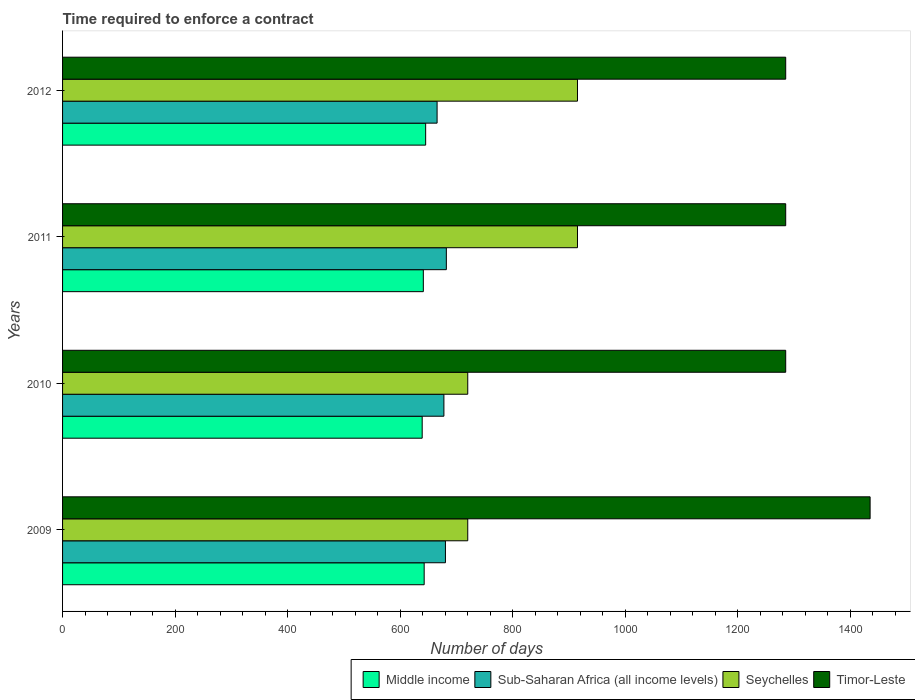How many bars are there on the 4th tick from the bottom?
Your answer should be very brief. 4. What is the label of the 2nd group of bars from the top?
Give a very brief answer. 2011. What is the number of days required to enforce a contract in Sub-Saharan Africa (all income levels) in 2012?
Provide a succinct answer. 665.52. Across all years, what is the maximum number of days required to enforce a contract in Seychelles?
Provide a succinct answer. 915. Across all years, what is the minimum number of days required to enforce a contract in Seychelles?
Keep it short and to the point. 720. In which year was the number of days required to enforce a contract in Timor-Leste minimum?
Offer a very short reply. 2010. What is the total number of days required to enforce a contract in Timor-Leste in the graph?
Give a very brief answer. 5290. What is the difference between the number of days required to enforce a contract in Sub-Saharan Africa (all income levels) in 2011 and the number of days required to enforce a contract in Timor-Leste in 2012?
Provide a short and direct response. -603.02. What is the average number of days required to enforce a contract in Middle income per year?
Your answer should be compact. 641.97. In the year 2010, what is the difference between the number of days required to enforce a contract in Sub-Saharan Africa (all income levels) and number of days required to enforce a contract in Seychelles?
Give a very brief answer. -42.36. What is the ratio of the number of days required to enforce a contract in Sub-Saharan Africa (all income levels) in 2010 to that in 2012?
Your response must be concise. 1.02. What is the difference between the highest and the second highest number of days required to enforce a contract in Sub-Saharan Africa (all income levels)?
Make the answer very short. 1.62. What is the difference between the highest and the lowest number of days required to enforce a contract in Timor-Leste?
Provide a short and direct response. 150. In how many years, is the number of days required to enforce a contract in Middle income greater than the average number of days required to enforce a contract in Middle income taken over all years?
Ensure brevity in your answer.  2. Is it the case that in every year, the sum of the number of days required to enforce a contract in Timor-Leste and number of days required to enforce a contract in Sub-Saharan Africa (all income levels) is greater than the sum of number of days required to enforce a contract in Seychelles and number of days required to enforce a contract in Middle income?
Offer a terse response. Yes. What does the 2nd bar from the top in 2009 represents?
Ensure brevity in your answer.  Seychelles. What does the 1st bar from the bottom in 2011 represents?
Offer a very short reply. Middle income. Is it the case that in every year, the sum of the number of days required to enforce a contract in Seychelles and number of days required to enforce a contract in Timor-Leste is greater than the number of days required to enforce a contract in Sub-Saharan Africa (all income levels)?
Provide a succinct answer. Yes. How many bars are there?
Your answer should be compact. 16. How many years are there in the graph?
Your answer should be very brief. 4. Does the graph contain any zero values?
Offer a very short reply. No. How many legend labels are there?
Your response must be concise. 4. What is the title of the graph?
Offer a terse response. Time required to enforce a contract. What is the label or title of the X-axis?
Ensure brevity in your answer.  Number of days. What is the Number of days in Middle income in 2009?
Your answer should be compact. 642.56. What is the Number of days in Sub-Saharan Africa (all income levels) in 2009?
Your response must be concise. 680.36. What is the Number of days in Seychelles in 2009?
Provide a short and direct response. 720. What is the Number of days in Timor-Leste in 2009?
Offer a terse response. 1435. What is the Number of days in Middle income in 2010?
Your answer should be compact. 639.04. What is the Number of days in Sub-Saharan Africa (all income levels) in 2010?
Ensure brevity in your answer.  677.64. What is the Number of days in Seychelles in 2010?
Your response must be concise. 720. What is the Number of days of Timor-Leste in 2010?
Your answer should be compact. 1285. What is the Number of days in Middle income in 2011?
Your answer should be compact. 641.06. What is the Number of days of Sub-Saharan Africa (all income levels) in 2011?
Provide a succinct answer. 681.98. What is the Number of days in Seychelles in 2011?
Ensure brevity in your answer.  915. What is the Number of days of Timor-Leste in 2011?
Offer a very short reply. 1285. What is the Number of days in Middle income in 2012?
Offer a very short reply. 645.22. What is the Number of days of Sub-Saharan Africa (all income levels) in 2012?
Keep it short and to the point. 665.52. What is the Number of days in Seychelles in 2012?
Provide a succinct answer. 915. What is the Number of days in Timor-Leste in 2012?
Your answer should be compact. 1285. Across all years, what is the maximum Number of days of Middle income?
Your answer should be very brief. 645.22. Across all years, what is the maximum Number of days of Sub-Saharan Africa (all income levels)?
Offer a very short reply. 681.98. Across all years, what is the maximum Number of days of Seychelles?
Give a very brief answer. 915. Across all years, what is the maximum Number of days of Timor-Leste?
Make the answer very short. 1435. Across all years, what is the minimum Number of days of Middle income?
Keep it short and to the point. 639.04. Across all years, what is the minimum Number of days of Sub-Saharan Africa (all income levels)?
Your response must be concise. 665.52. Across all years, what is the minimum Number of days of Seychelles?
Ensure brevity in your answer.  720. Across all years, what is the minimum Number of days in Timor-Leste?
Your answer should be very brief. 1285. What is the total Number of days of Middle income in the graph?
Keep it short and to the point. 2567.87. What is the total Number of days of Sub-Saharan Africa (all income levels) in the graph?
Give a very brief answer. 2705.5. What is the total Number of days of Seychelles in the graph?
Ensure brevity in your answer.  3270. What is the total Number of days of Timor-Leste in the graph?
Ensure brevity in your answer.  5290. What is the difference between the Number of days of Middle income in 2009 and that in 2010?
Give a very brief answer. 3.51. What is the difference between the Number of days in Sub-Saharan Africa (all income levels) in 2009 and that in 2010?
Offer a very short reply. 2.71. What is the difference between the Number of days of Seychelles in 2009 and that in 2010?
Offer a very short reply. 0. What is the difference between the Number of days of Timor-Leste in 2009 and that in 2010?
Provide a succinct answer. 150. What is the difference between the Number of days in Sub-Saharan Africa (all income levels) in 2009 and that in 2011?
Your answer should be very brief. -1.62. What is the difference between the Number of days of Seychelles in 2009 and that in 2011?
Provide a short and direct response. -195. What is the difference between the Number of days of Timor-Leste in 2009 and that in 2011?
Provide a short and direct response. 150. What is the difference between the Number of days of Middle income in 2009 and that in 2012?
Provide a succinct answer. -2.66. What is the difference between the Number of days in Sub-Saharan Africa (all income levels) in 2009 and that in 2012?
Offer a terse response. 14.83. What is the difference between the Number of days in Seychelles in 2009 and that in 2012?
Make the answer very short. -195. What is the difference between the Number of days of Timor-Leste in 2009 and that in 2012?
Ensure brevity in your answer.  150. What is the difference between the Number of days in Middle income in 2010 and that in 2011?
Your answer should be compact. -2.01. What is the difference between the Number of days in Sub-Saharan Africa (all income levels) in 2010 and that in 2011?
Offer a terse response. -4.33. What is the difference between the Number of days in Seychelles in 2010 and that in 2011?
Offer a very short reply. -195. What is the difference between the Number of days in Timor-Leste in 2010 and that in 2011?
Make the answer very short. 0. What is the difference between the Number of days of Middle income in 2010 and that in 2012?
Your answer should be very brief. -6.17. What is the difference between the Number of days of Sub-Saharan Africa (all income levels) in 2010 and that in 2012?
Offer a very short reply. 12.12. What is the difference between the Number of days of Seychelles in 2010 and that in 2012?
Keep it short and to the point. -195. What is the difference between the Number of days of Middle income in 2011 and that in 2012?
Your answer should be compact. -4.16. What is the difference between the Number of days in Sub-Saharan Africa (all income levels) in 2011 and that in 2012?
Give a very brief answer. 16.46. What is the difference between the Number of days of Seychelles in 2011 and that in 2012?
Ensure brevity in your answer.  0. What is the difference between the Number of days of Middle income in 2009 and the Number of days of Sub-Saharan Africa (all income levels) in 2010?
Your answer should be compact. -35.09. What is the difference between the Number of days in Middle income in 2009 and the Number of days in Seychelles in 2010?
Your answer should be very brief. -77.44. What is the difference between the Number of days in Middle income in 2009 and the Number of days in Timor-Leste in 2010?
Provide a short and direct response. -642.44. What is the difference between the Number of days in Sub-Saharan Africa (all income levels) in 2009 and the Number of days in Seychelles in 2010?
Offer a very short reply. -39.64. What is the difference between the Number of days in Sub-Saharan Africa (all income levels) in 2009 and the Number of days in Timor-Leste in 2010?
Make the answer very short. -604.64. What is the difference between the Number of days in Seychelles in 2009 and the Number of days in Timor-Leste in 2010?
Offer a terse response. -565. What is the difference between the Number of days of Middle income in 2009 and the Number of days of Sub-Saharan Africa (all income levels) in 2011?
Your answer should be compact. -39.42. What is the difference between the Number of days in Middle income in 2009 and the Number of days in Seychelles in 2011?
Your answer should be very brief. -272.44. What is the difference between the Number of days of Middle income in 2009 and the Number of days of Timor-Leste in 2011?
Keep it short and to the point. -642.44. What is the difference between the Number of days of Sub-Saharan Africa (all income levels) in 2009 and the Number of days of Seychelles in 2011?
Provide a short and direct response. -234.64. What is the difference between the Number of days of Sub-Saharan Africa (all income levels) in 2009 and the Number of days of Timor-Leste in 2011?
Give a very brief answer. -604.64. What is the difference between the Number of days in Seychelles in 2009 and the Number of days in Timor-Leste in 2011?
Give a very brief answer. -565. What is the difference between the Number of days of Middle income in 2009 and the Number of days of Sub-Saharan Africa (all income levels) in 2012?
Offer a very short reply. -22.97. What is the difference between the Number of days in Middle income in 2009 and the Number of days in Seychelles in 2012?
Provide a short and direct response. -272.44. What is the difference between the Number of days of Middle income in 2009 and the Number of days of Timor-Leste in 2012?
Offer a very short reply. -642.44. What is the difference between the Number of days in Sub-Saharan Africa (all income levels) in 2009 and the Number of days in Seychelles in 2012?
Provide a succinct answer. -234.64. What is the difference between the Number of days in Sub-Saharan Africa (all income levels) in 2009 and the Number of days in Timor-Leste in 2012?
Provide a succinct answer. -604.64. What is the difference between the Number of days of Seychelles in 2009 and the Number of days of Timor-Leste in 2012?
Your answer should be compact. -565. What is the difference between the Number of days in Middle income in 2010 and the Number of days in Sub-Saharan Africa (all income levels) in 2011?
Make the answer very short. -42.93. What is the difference between the Number of days of Middle income in 2010 and the Number of days of Seychelles in 2011?
Your answer should be very brief. -275.96. What is the difference between the Number of days of Middle income in 2010 and the Number of days of Timor-Leste in 2011?
Offer a very short reply. -645.96. What is the difference between the Number of days of Sub-Saharan Africa (all income levels) in 2010 and the Number of days of Seychelles in 2011?
Provide a succinct answer. -237.36. What is the difference between the Number of days of Sub-Saharan Africa (all income levels) in 2010 and the Number of days of Timor-Leste in 2011?
Your answer should be compact. -607.36. What is the difference between the Number of days in Seychelles in 2010 and the Number of days in Timor-Leste in 2011?
Give a very brief answer. -565. What is the difference between the Number of days of Middle income in 2010 and the Number of days of Sub-Saharan Africa (all income levels) in 2012?
Provide a succinct answer. -26.48. What is the difference between the Number of days of Middle income in 2010 and the Number of days of Seychelles in 2012?
Keep it short and to the point. -275.96. What is the difference between the Number of days in Middle income in 2010 and the Number of days in Timor-Leste in 2012?
Offer a very short reply. -645.96. What is the difference between the Number of days in Sub-Saharan Africa (all income levels) in 2010 and the Number of days in Seychelles in 2012?
Your response must be concise. -237.36. What is the difference between the Number of days of Sub-Saharan Africa (all income levels) in 2010 and the Number of days of Timor-Leste in 2012?
Ensure brevity in your answer.  -607.36. What is the difference between the Number of days in Seychelles in 2010 and the Number of days in Timor-Leste in 2012?
Offer a terse response. -565. What is the difference between the Number of days of Middle income in 2011 and the Number of days of Sub-Saharan Africa (all income levels) in 2012?
Keep it short and to the point. -24.47. What is the difference between the Number of days of Middle income in 2011 and the Number of days of Seychelles in 2012?
Your answer should be compact. -273.94. What is the difference between the Number of days in Middle income in 2011 and the Number of days in Timor-Leste in 2012?
Give a very brief answer. -643.94. What is the difference between the Number of days in Sub-Saharan Africa (all income levels) in 2011 and the Number of days in Seychelles in 2012?
Give a very brief answer. -233.02. What is the difference between the Number of days of Sub-Saharan Africa (all income levels) in 2011 and the Number of days of Timor-Leste in 2012?
Provide a succinct answer. -603.02. What is the difference between the Number of days in Seychelles in 2011 and the Number of days in Timor-Leste in 2012?
Give a very brief answer. -370. What is the average Number of days of Middle income per year?
Your answer should be compact. 641.97. What is the average Number of days of Sub-Saharan Africa (all income levels) per year?
Your answer should be very brief. 676.37. What is the average Number of days of Seychelles per year?
Provide a short and direct response. 817.5. What is the average Number of days of Timor-Leste per year?
Offer a terse response. 1322.5. In the year 2009, what is the difference between the Number of days in Middle income and Number of days in Sub-Saharan Africa (all income levels)?
Provide a short and direct response. -37.8. In the year 2009, what is the difference between the Number of days of Middle income and Number of days of Seychelles?
Give a very brief answer. -77.44. In the year 2009, what is the difference between the Number of days in Middle income and Number of days in Timor-Leste?
Offer a terse response. -792.44. In the year 2009, what is the difference between the Number of days of Sub-Saharan Africa (all income levels) and Number of days of Seychelles?
Offer a terse response. -39.64. In the year 2009, what is the difference between the Number of days of Sub-Saharan Africa (all income levels) and Number of days of Timor-Leste?
Your answer should be very brief. -754.64. In the year 2009, what is the difference between the Number of days of Seychelles and Number of days of Timor-Leste?
Give a very brief answer. -715. In the year 2010, what is the difference between the Number of days of Middle income and Number of days of Sub-Saharan Africa (all income levels)?
Provide a succinct answer. -38.6. In the year 2010, what is the difference between the Number of days in Middle income and Number of days in Seychelles?
Provide a short and direct response. -80.96. In the year 2010, what is the difference between the Number of days of Middle income and Number of days of Timor-Leste?
Provide a short and direct response. -645.96. In the year 2010, what is the difference between the Number of days of Sub-Saharan Africa (all income levels) and Number of days of Seychelles?
Offer a terse response. -42.36. In the year 2010, what is the difference between the Number of days in Sub-Saharan Africa (all income levels) and Number of days in Timor-Leste?
Ensure brevity in your answer.  -607.36. In the year 2010, what is the difference between the Number of days in Seychelles and Number of days in Timor-Leste?
Give a very brief answer. -565. In the year 2011, what is the difference between the Number of days in Middle income and Number of days in Sub-Saharan Africa (all income levels)?
Ensure brevity in your answer.  -40.92. In the year 2011, what is the difference between the Number of days of Middle income and Number of days of Seychelles?
Make the answer very short. -273.94. In the year 2011, what is the difference between the Number of days in Middle income and Number of days in Timor-Leste?
Make the answer very short. -643.94. In the year 2011, what is the difference between the Number of days of Sub-Saharan Africa (all income levels) and Number of days of Seychelles?
Your answer should be compact. -233.02. In the year 2011, what is the difference between the Number of days in Sub-Saharan Africa (all income levels) and Number of days in Timor-Leste?
Your answer should be very brief. -603.02. In the year 2011, what is the difference between the Number of days of Seychelles and Number of days of Timor-Leste?
Ensure brevity in your answer.  -370. In the year 2012, what is the difference between the Number of days of Middle income and Number of days of Sub-Saharan Africa (all income levels)?
Offer a terse response. -20.3. In the year 2012, what is the difference between the Number of days of Middle income and Number of days of Seychelles?
Provide a short and direct response. -269.78. In the year 2012, what is the difference between the Number of days of Middle income and Number of days of Timor-Leste?
Your answer should be compact. -639.78. In the year 2012, what is the difference between the Number of days in Sub-Saharan Africa (all income levels) and Number of days in Seychelles?
Provide a succinct answer. -249.48. In the year 2012, what is the difference between the Number of days of Sub-Saharan Africa (all income levels) and Number of days of Timor-Leste?
Give a very brief answer. -619.48. In the year 2012, what is the difference between the Number of days of Seychelles and Number of days of Timor-Leste?
Keep it short and to the point. -370. What is the ratio of the Number of days in Middle income in 2009 to that in 2010?
Provide a short and direct response. 1.01. What is the ratio of the Number of days of Sub-Saharan Africa (all income levels) in 2009 to that in 2010?
Make the answer very short. 1. What is the ratio of the Number of days in Timor-Leste in 2009 to that in 2010?
Make the answer very short. 1.12. What is the ratio of the Number of days of Seychelles in 2009 to that in 2011?
Your answer should be compact. 0.79. What is the ratio of the Number of days in Timor-Leste in 2009 to that in 2011?
Ensure brevity in your answer.  1.12. What is the ratio of the Number of days of Sub-Saharan Africa (all income levels) in 2009 to that in 2012?
Provide a short and direct response. 1.02. What is the ratio of the Number of days of Seychelles in 2009 to that in 2012?
Your response must be concise. 0.79. What is the ratio of the Number of days of Timor-Leste in 2009 to that in 2012?
Offer a terse response. 1.12. What is the ratio of the Number of days in Middle income in 2010 to that in 2011?
Keep it short and to the point. 1. What is the ratio of the Number of days of Seychelles in 2010 to that in 2011?
Your response must be concise. 0.79. What is the ratio of the Number of days in Timor-Leste in 2010 to that in 2011?
Provide a succinct answer. 1. What is the ratio of the Number of days in Middle income in 2010 to that in 2012?
Your answer should be very brief. 0.99. What is the ratio of the Number of days of Sub-Saharan Africa (all income levels) in 2010 to that in 2012?
Ensure brevity in your answer.  1.02. What is the ratio of the Number of days in Seychelles in 2010 to that in 2012?
Your response must be concise. 0.79. What is the ratio of the Number of days in Timor-Leste in 2010 to that in 2012?
Ensure brevity in your answer.  1. What is the ratio of the Number of days of Middle income in 2011 to that in 2012?
Make the answer very short. 0.99. What is the ratio of the Number of days in Sub-Saharan Africa (all income levels) in 2011 to that in 2012?
Give a very brief answer. 1.02. What is the ratio of the Number of days in Seychelles in 2011 to that in 2012?
Your answer should be compact. 1. What is the difference between the highest and the second highest Number of days of Middle income?
Your answer should be very brief. 2.66. What is the difference between the highest and the second highest Number of days of Sub-Saharan Africa (all income levels)?
Offer a very short reply. 1.62. What is the difference between the highest and the second highest Number of days in Timor-Leste?
Give a very brief answer. 150. What is the difference between the highest and the lowest Number of days in Middle income?
Offer a very short reply. 6.17. What is the difference between the highest and the lowest Number of days in Sub-Saharan Africa (all income levels)?
Provide a succinct answer. 16.46. What is the difference between the highest and the lowest Number of days in Seychelles?
Keep it short and to the point. 195. What is the difference between the highest and the lowest Number of days in Timor-Leste?
Your answer should be compact. 150. 